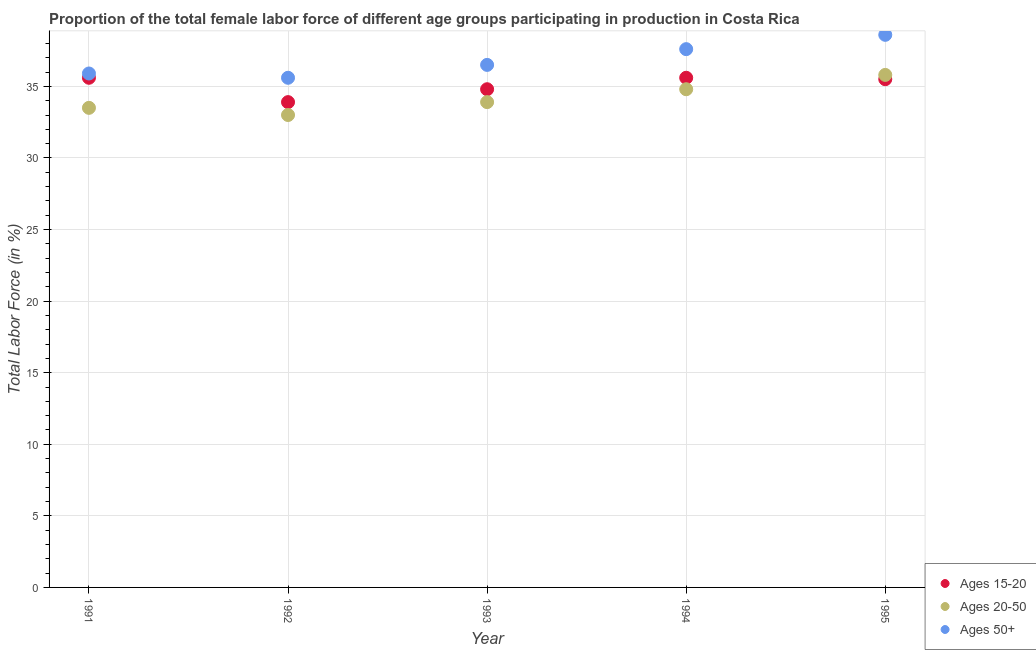Is the number of dotlines equal to the number of legend labels?
Make the answer very short. Yes. What is the percentage of female labor force above age 50 in 1993?
Offer a terse response. 36.5. Across all years, what is the maximum percentage of female labor force within the age group 15-20?
Offer a terse response. 35.6. Across all years, what is the minimum percentage of female labor force above age 50?
Your response must be concise. 35.6. In which year was the percentage of female labor force within the age group 20-50 maximum?
Your answer should be compact. 1995. What is the total percentage of female labor force within the age group 20-50 in the graph?
Provide a short and direct response. 171. What is the difference between the percentage of female labor force within the age group 15-20 in 1993 and that in 1994?
Your response must be concise. -0.8. What is the average percentage of female labor force within the age group 15-20 per year?
Your answer should be compact. 35.08. In the year 1992, what is the difference between the percentage of female labor force within the age group 15-20 and percentage of female labor force above age 50?
Your answer should be compact. -1.7. What is the ratio of the percentage of female labor force within the age group 20-50 in 1992 to that in 1993?
Offer a terse response. 0.97. Is the percentage of female labor force within the age group 15-20 in 1991 less than that in 1995?
Ensure brevity in your answer.  No. Is the difference between the percentage of female labor force within the age group 20-50 in 1991 and 1995 greater than the difference between the percentage of female labor force above age 50 in 1991 and 1995?
Make the answer very short. Yes. In how many years, is the percentage of female labor force within the age group 20-50 greater than the average percentage of female labor force within the age group 20-50 taken over all years?
Provide a short and direct response. 2. Does the percentage of female labor force within the age group 20-50 monotonically increase over the years?
Provide a succinct answer. No. What is the difference between two consecutive major ticks on the Y-axis?
Offer a terse response. 5. Does the graph contain any zero values?
Offer a very short reply. No. How are the legend labels stacked?
Provide a succinct answer. Vertical. What is the title of the graph?
Give a very brief answer. Proportion of the total female labor force of different age groups participating in production in Costa Rica. What is the label or title of the X-axis?
Offer a very short reply. Year. What is the Total Labor Force (in %) of Ages 15-20 in 1991?
Your response must be concise. 35.6. What is the Total Labor Force (in %) of Ages 20-50 in 1991?
Offer a very short reply. 33.5. What is the Total Labor Force (in %) in Ages 50+ in 1991?
Provide a succinct answer. 35.9. What is the Total Labor Force (in %) of Ages 15-20 in 1992?
Ensure brevity in your answer.  33.9. What is the Total Labor Force (in %) in Ages 20-50 in 1992?
Provide a succinct answer. 33. What is the Total Labor Force (in %) in Ages 50+ in 1992?
Provide a short and direct response. 35.6. What is the Total Labor Force (in %) in Ages 15-20 in 1993?
Your answer should be very brief. 34.8. What is the Total Labor Force (in %) in Ages 20-50 in 1993?
Make the answer very short. 33.9. What is the Total Labor Force (in %) in Ages 50+ in 1993?
Offer a terse response. 36.5. What is the Total Labor Force (in %) of Ages 15-20 in 1994?
Provide a succinct answer. 35.6. What is the Total Labor Force (in %) of Ages 20-50 in 1994?
Offer a terse response. 34.8. What is the Total Labor Force (in %) in Ages 50+ in 1994?
Your answer should be very brief. 37.6. What is the Total Labor Force (in %) of Ages 15-20 in 1995?
Keep it short and to the point. 35.5. What is the Total Labor Force (in %) of Ages 20-50 in 1995?
Offer a terse response. 35.8. What is the Total Labor Force (in %) of Ages 50+ in 1995?
Your answer should be compact. 38.6. Across all years, what is the maximum Total Labor Force (in %) of Ages 15-20?
Keep it short and to the point. 35.6. Across all years, what is the maximum Total Labor Force (in %) of Ages 20-50?
Provide a short and direct response. 35.8. Across all years, what is the maximum Total Labor Force (in %) in Ages 50+?
Make the answer very short. 38.6. Across all years, what is the minimum Total Labor Force (in %) in Ages 15-20?
Provide a short and direct response. 33.9. Across all years, what is the minimum Total Labor Force (in %) in Ages 50+?
Your answer should be compact. 35.6. What is the total Total Labor Force (in %) in Ages 15-20 in the graph?
Ensure brevity in your answer.  175.4. What is the total Total Labor Force (in %) in Ages 20-50 in the graph?
Provide a succinct answer. 171. What is the total Total Labor Force (in %) in Ages 50+ in the graph?
Keep it short and to the point. 184.2. What is the difference between the Total Labor Force (in %) in Ages 15-20 in 1991 and that in 1992?
Offer a terse response. 1.7. What is the difference between the Total Labor Force (in %) in Ages 50+ in 1991 and that in 1992?
Your answer should be very brief. 0.3. What is the difference between the Total Labor Force (in %) in Ages 15-20 in 1991 and that in 1993?
Ensure brevity in your answer.  0.8. What is the difference between the Total Labor Force (in %) in Ages 20-50 in 1991 and that in 1994?
Provide a short and direct response. -1.3. What is the difference between the Total Labor Force (in %) of Ages 50+ in 1992 and that in 1993?
Your answer should be compact. -0.9. What is the difference between the Total Labor Force (in %) in Ages 15-20 in 1992 and that in 1994?
Provide a succinct answer. -1.7. What is the difference between the Total Labor Force (in %) of Ages 50+ in 1992 and that in 1994?
Keep it short and to the point. -2. What is the difference between the Total Labor Force (in %) in Ages 20-50 in 1993 and that in 1994?
Your answer should be very brief. -0.9. What is the difference between the Total Labor Force (in %) of Ages 20-50 in 1993 and that in 1995?
Your answer should be very brief. -1.9. What is the difference between the Total Labor Force (in %) in Ages 15-20 in 1994 and that in 1995?
Make the answer very short. 0.1. What is the difference between the Total Labor Force (in %) in Ages 20-50 in 1994 and that in 1995?
Keep it short and to the point. -1. What is the difference between the Total Labor Force (in %) of Ages 15-20 in 1991 and the Total Labor Force (in %) of Ages 50+ in 1992?
Provide a short and direct response. 0. What is the difference between the Total Labor Force (in %) in Ages 20-50 in 1991 and the Total Labor Force (in %) in Ages 50+ in 1992?
Provide a succinct answer. -2.1. What is the difference between the Total Labor Force (in %) in Ages 15-20 in 1991 and the Total Labor Force (in %) in Ages 20-50 in 1993?
Give a very brief answer. 1.7. What is the difference between the Total Labor Force (in %) of Ages 15-20 in 1991 and the Total Labor Force (in %) of Ages 50+ in 1993?
Ensure brevity in your answer.  -0.9. What is the difference between the Total Labor Force (in %) of Ages 20-50 in 1991 and the Total Labor Force (in %) of Ages 50+ in 1993?
Ensure brevity in your answer.  -3. What is the difference between the Total Labor Force (in %) in Ages 15-20 in 1991 and the Total Labor Force (in %) in Ages 20-50 in 1994?
Make the answer very short. 0.8. What is the difference between the Total Labor Force (in %) of Ages 20-50 in 1991 and the Total Labor Force (in %) of Ages 50+ in 1994?
Ensure brevity in your answer.  -4.1. What is the difference between the Total Labor Force (in %) in Ages 15-20 in 1992 and the Total Labor Force (in %) in Ages 20-50 in 1993?
Make the answer very short. 0. What is the difference between the Total Labor Force (in %) of Ages 20-50 in 1992 and the Total Labor Force (in %) of Ages 50+ in 1993?
Offer a terse response. -3.5. What is the difference between the Total Labor Force (in %) of Ages 20-50 in 1992 and the Total Labor Force (in %) of Ages 50+ in 1994?
Your response must be concise. -4.6. What is the difference between the Total Labor Force (in %) in Ages 15-20 in 1992 and the Total Labor Force (in %) in Ages 20-50 in 1995?
Your response must be concise. -1.9. What is the difference between the Total Labor Force (in %) in Ages 20-50 in 1992 and the Total Labor Force (in %) in Ages 50+ in 1995?
Make the answer very short. -5.6. What is the difference between the Total Labor Force (in %) of Ages 15-20 in 1993 and the Total Labor Force (in %) of Ages 20-50 in 1995?
Provide a succinct answer. -1. What is the difference between the Total Labor Force (in %) in Ages 15-20 in 1993 and the Total Labor Force (in %) in Ages 50+ in 1995?
Give a very brief answer. -3.8. What is the difference between the Total Labor Force (in %) in Ages 15-20 in 1994 and the Total Labor Force (in %) in Ages 20-50 in 1995?
Provide a short and direct response. -0.2. What is the difference between the Total Labor Force (in %) in Ages 20-50 in 1994 and the Total Labor Force (in %) in Ages 50+ in 1995?
Your answer should be compact. -3.8. What is the average Total Labor Force (in %) in Ages 15-20 per year?
Keep it short and to the point. 35.08. What is the average Total Labor Force (in %) of Ages 20-50 per year?
Ensure brevity in your answer.  34.2. What is the average Total Labor Force (in %) of Ages 50+ per year?
Your answer should be compact. 36.84. In the year 1991, what is the difference between the Total Labor Force (in %) in Ages 15-20 and Total Labor Force (in %) in Ages 20-50?
Your answer should be very brief. 2.1. In the year 1991, what is the difference between the Total Labor Force (in %) in Ages 20-50 and Total Labor Force (in %) in Ages 50+?
Ensure brevity in your answer.  -2.4. In the year 1992, what is the difference between the Total Labor Force (in %) of Ages 15-20 and Total Labor Force (in %) of Ages 20-50?
Your answer should be very brief. 0.9. In the year 1992, what is the difference between the Total Labor Force (in %) of Ages 15-20 and Total Labor Force (in %) of Ages 50+?
Ensure brevity in your answer.  -1.7. In the year 1992, what is the difference between the Total Labor Force (in %) in Ages 20-50 and Total Labor Force (in %) in Ages 50+?
Ensure brevity in your answer.  -2.6. In the year 1993, what is the difference between the Total Labor Force (in %) of Ages 15-20 and Total Labor Force (in %) of Ages 20-50?
Your response must be concise. 0.9. In the year 1994, what is the difference between the Total Labor Force (in %) of Ages 15-20 and Total Labor Force (in %) of Ages 20-50?
Make the answer very short. 0.8. In the year 1994, what is the difference between the Total Labor Force (in %) in Ages 15-20 and Total Labor Force (in %) in Ages 50+?
Offer a terse response. -2. In the year 1995, what is the difference between the Total Labor Force (in %) of Ages 15-20 and Total Labor Force (in %) of Ages 20-50?
Your answer should be very brief. -0.3. In the year 1995, what is the difference between the Total Labor Force (in %) in Ages 15-20 and Total Labor Force (in %) in Ages 50+?
Provide a succinct answer. -3.1. What is the ratio of the Total Labor Force (in %) of Ages 15-20 in 1991 to that in 1992?
Offer a terse response. 1.05. What is the ratio of the Total Labor Force (in %) in Ages 20-50 in 1991 to that in 1992?
Keep it short and to the point. 1.02. What is the ratio of the Total Labor Force (in %) in Ages 50+ in 1991 to that in 1992?
Provide a succinct answer. 1.01. What is the ratio of the Total Labor Force (in %) of Ages 20-50 in 1991 to that in 1993?
Your response must be concise. 0.99. What is the ratio of the Total Labor Force (in %) of Ages 50+ in 1991 to that in 1993?
Your answer should be very brief. 0.98. What is the ratio of the Total Labor Force (in %) of Ages 15-20 in 1991 to that in 1994?
Offer a terse response. 1. What is the ratio of the Total Labor Force (in %) of Ages 20-50 in 1991 to that in 1994?
Ensure brevity in your answer.  0.96. What is the ratio of the Total Labor Force (in %) in Ages 50+ in 1991 to that in 1994?
Your answer should be compact. 0.95. What is the ratio of the Total Labor Force (in %) in Ages 20-50 in 1991 to that in 1995?
Give a very brief answer. 0.94. What is the ratio of the Total Labor Force (in %) of Ages 50+ in 1991 to that in 1995?
Give a very brief answer. 0.93. What is the ratio of the Total Labor Force (in %) in Ages 15-20 in 1992 to that in 1993?
Ensure brevity in your answer.  0.97. What is the ratio of the Total Labor Force (in %) in Ages 20-50 in 1992 to that in 1993?
Offer a very short reply. 0.97. What is the ratio of the Total Labor Force (in %) of Ages 50+ in 1992 to that in 1993?
Provide a short and direct response. 0.98. What is the ratio of the Total Labor Force (in %) of Ages 15-20 in 1992 to that in 1994?
Keep it short and to the point. 0.95. What is the ratio of the Total Labor Force (in %) in Ages 20-50 in 1992 to that in 1994?
Provide a succinct answer. 0.95. What is the ratio of the Total Labor Force (in %) in Ages 50+ in 1992 to that in 1994?
Your answer should be very brief. 0.95. What is the ratio of the Total Labor Force (in %) of Ages 15-20 in 1992 to that in 1995?
Make the answer very short. 0.95. What is the ratio of the Total Labor Force (in %) in Ages 20-50 in 1992 to that in 1995?
Make the answer very short. 0.92. What is the ratio of the Total Labor Force (in %) of Ages 50+ in 1992 to that in 1995?
Provide a succinct answer. 0.92. What is the ratio of the Total Labor Force (in %) in Ages 15-20 in 1993 to that in 1994?
Your answer should be very brief. 0.98. What is the ratio of the Total Labor Force (in %) in Ages 20-50 in 1993 to that in 1994?
Offer a very short reply. 0.97. What is the ratio of the Total Labor Force (in %) in Ages 50+ in 1993 to that in 1994?
Your response must be concise. 0.97. What is the ratio of the Total Labor Force (in %) in Ages 15-20 in 1993 to that in 1995?
Ensure brevity in your answer.  0.98. What is the ratio of the Total Labor Force (in %) of Ages 20-50 in 1993 to that in 1995?
Provide a short and direct response. 0.95. What is the ratio of the Total Labor Force (in %) of Ages 50+ in 1993 to that in 1995?
Give a very brief answer. 0.95. What is the ratio of the Total Labor Force (in %) in Ages 20-50 in 1994 to that in 1995?
Keep it short and to the point. 0.97. What is the ratio of the Total Labor Force (in %) in Ages 50+ in 1994 to that in 1995?
Make the answer very short. 0.97. What is the difference between the highest and the second highest Total Labor Force (in %) in Ages 15-20?
Your answer should be compact. 0. What is the difference between the highest and the lowest Total Labor Force (in %) in Ages 15-20?
Provide a short and direct response. 1.7. What is the difference between the highest and the lowest Total Labor Force (in %) of Ages 20-50?
Provide a succinct answer. 2.8. What is the difference between the highest and the lowest Total Labor Force (in %) in Ages 50+?
Provide a succinct answer. 3. 